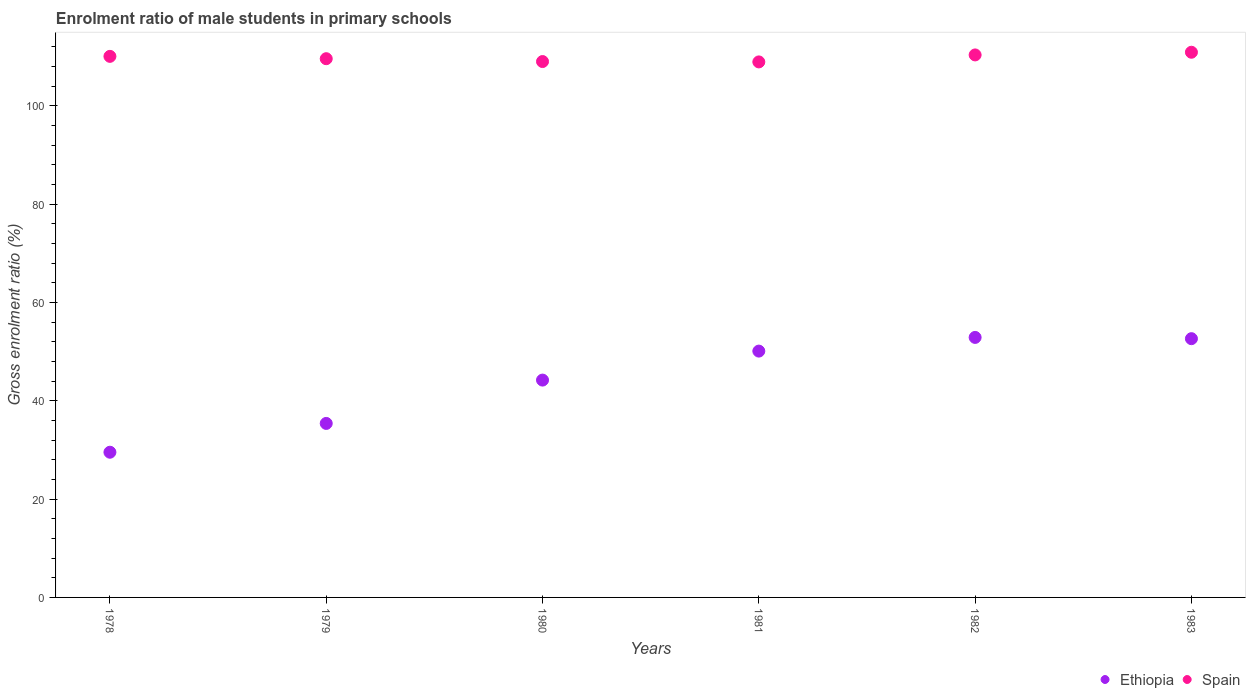How many different coloured dotlines are there?
Ensure brevity in your answer.  2. Is the number of dotlines equal to the number of legend labels?
Provide a short and direct response. Yes. What is the enrolment ratio of male students in primary schools in Ethiopia in 1983?
Provide a short and direct response. 52.64. Across all years, what is the maximum enrolment ratio of male students in primary schools in Ethiopia?
Offer a very short reply. 52.89. Across all years, what is the minimum enrolment ratio of male students in primary schools in Spain?
Ensure brevity in your answer.  108.94. In which year was the enrolment ratio of male students in primary schools in Spain minimum?
Your response must be concise. 1981. What is the total enrolment ratio of male students in primary schools in Ethiopia in the graph?
Keep it short and to the point. 264.79. What is the difference between the enrolment ratio of male students in primary schools in Spain in 1978 and that in 1981?
Keep it short and to the point. 1.13. What is the difference between the enrolment ratio of male students in primary schools in Spain in 1983 and the enrolment ratio of male students in primary schools in Ethiopia in 1978?
Make the answer very short. 81.37. What is the average enrolment ratio of male students in primary schools in Spain per year?
Your answer should be compact. 109.82. In the year 1981, what is the difference between the enrolment ratio of male students in primary schools in Ethiopia and enrolment ratio of male students in primary schools in Spain?
Your response must be concise. -58.83. In how many years, is the enrolment ratio of male students in primary schools in Spain greater than 16 %?
Keep it short and to the point. 6. What is the ratio of the enrolment ratio of male students in primary schools in Ethiopia in 1980 to that in 1982?
Your answer should be very brief. 0.84. Is the enrolment ratio of male students in primary schools in Ethiopia in 1979 less than that in 1981?
Your answer should be compact. Yes. What is the difference between the highest and the second highest enrolment ratio of male students in primary schools in Spain?
Make the answer very short. 0.54. What is the difference between the highest and the lowest enrolment ratio of male students in primary schools in Ethiopia?
Your answer should be very brief. 23.36. Does the enrolment ratio of male students in primary schools in Spain monotonically increase over the years?
Your answer should be compact. No. Is the enrolment ratio of male students in primary schools in Ethiopia strictly greater than the enrolment ratio of male students in primary schools in Spain over the years?
Offer a terse response. No. How many years are there in the graph?
Make the answer very short. 6. Does the graph contain grids?
Provide a succinct answer. No. Where does the legend appear in the graph?
Offer a terse response. Bottom right. What is the title of the graph?
Provide a succinct answer. Enrolment ratio of male students in primary schools. What is the label or title of the X-axis?
Your answer should be compact. Years. What is the Gross enrolment ratio (%) in Ethiopia in 1978?
Keep it short and to the point. 29.54. What is the Gross enrolment ratio (%) of Spain in 1978?
Your answer should be very brief. 110.07. What is the Gross enrolment ratio (%) in Ethiopia in 1979?
Provide a short and direct response. 35.4. What is the Gross enrolment ratio (%) in Spain in 1979?
Your answer should be compact. 109.59. What is the Gross enrolment ratio (%) in Ethiopia in 1980?
Keep it short and to the point. 44.21. What is the Gross enrolment ratio (%) of Spain in 1980?
Your answer should be compact. 109.02. What is the Gross enrolment ratio (%) in Ethiopia in 1981?
Your response must be concise. 50.11. What is the Gross enrolment ratio (%) of Spain in 1981?
Your response must be concise. 108.94. What is the Gross enrolment ratio (%) of Ethiopia in 1982?
Your answer should be compact. 52.89. What is the Gross enrolment ratio (%) in Spain in 1982?
Keep it short and to the point. 110.36. What is the Gross enrolment ratio (%) in Ethiopia in 1983?
Provide a succinct answer. 52.64. What is the Gross enrolment ratio (%) of Spain in 1983?
Ensure brevity in your answer.  110.91. Across all years, what is the maximum Gross enrolment ratio (%) of Ethiopia?
Keep it short and to the point. 52.89. Across all years, what is the maximum Gross enrolment ratio (%) in Spain?
Make the answer very short. 110.91. Across all years, what is the minimum Gross enrolment ratio (%) of Ethiopia?
Your response must be concise. 29.54. Across all years, what is the minimum Gross enrolment ratio (%) in Spain?
Provide a short and direct response. 108.94. What is the total Gross enrolment ratio (%) of Ethiopia in the graph?
Provide a succinct answer. 264.79. What is the total Gross enrolment ratio (%) in Spain in the graph?
Offer a very short reply. 658.89. What is the difference between the Gross enrolment ratio (%) in Ethiopia in 1978 and that in 1979?
Provide a succinct answer. -5.86. What is the difference between the Gross enrolment ratio (%) in Spain in 1978 and that in 1979?
Give a very brief answer. 0.48. What is the difference between the Gross enrolment ratio (%) in Ethiopia in 1978 and that in 1980?
Ensure brevity in your answer.  -14.68. What is the difference between the Gross enrolment ratio (%) of Spain in 1978 and that in 1980?
Offer a very short reply. 1.06. What is the difference between the Gross enrolment ratio (%) of Ethiopia in 1978 and that in 1981?
Your response must be concise. -20.57. What is the difference between the Gross enrolment ratio (%) in Spain in 1978 and that in 1981?
Provide a short and direct response. 1.13. What is the difference between the Gross enrolment ratio (%) of Ethiopia in 1978 and that in 1982?
Your response must be concise. -23.36. What is the difference between the Gross enrolment ratio (%) of Spain in 1978 and that in 1982?
Provide a succinct answer. -0.29. What is the difference between the Gross enrolment ratio (%) of Ethiopia in 1978 and that in 1983?
Your answer should be compact. -23.1. What is the difference between the Gross enrolment ratio (%) in Spain in 1978 and that in 1983?
Offer a very short reply. -0.84. What is the difference between the Gross enrolment ratio (%) in Ethiopia in 1979 and that in 1980?
Your response must be concise. -8.81. What is the difference between the Gross enrolment ratio (%) of Spain in 1979 and that in 1980?
Your answer should be compact. 0.58. What is the difference between the Gross enrolment ratio (%) of Ethiopia in 1979 and that in 1981?
Your response must be concise. -14.71. What is the difference between the Gross enrolment ratio (%) in Spain in 1979 and that in 1981?
Make the answer very short. 0.65. What is the difference between the Gross enrolment ratio (%) in Ethiopia in 1979 and that in 1982?
Keep it short and to the point. -17.5. What is the difference between the Gross enrolment ratio (%) of Spain in 1979 and that in 1982?
Offer a very short reply. -0.77. What is the difference between the Gross enrolment ratio (%) of Ethiopia in 1979 and that in 1983?
Offer a terse response. -17.24. What is the difference between the Gross enrolment ratio (%) in Spain in 1979 and that in 1983?
Ensure brevity in your answer.  -1.31. What is the difference between the Gross enrolment ratio (%) in Ethiopia in 1980 and that in 1981?
Keep it short and to the point. -5.9. What is the difference between the Gross enrolment ratio (%) of Spain in 1980 and that in 1981?
Ensure brevity in your answer.  0.07. What is the difference between the Gross enrolment ratio (%) in Ethiopia in 1980 and that in 1982?
Offer a terse response. -8.68. What is the difference between the Gross enrolment ratio (%) in Spain in 1980 and that in 1982?
Ensure brevity in your answer.  -1.35. What is the difference between the Gross enrolment ratio (%) in Ethiopia in 1980 and that in 1983?
Provide a succinct answer. -8.43. What is the difference between the Gross enrolment ratio (%) in Spain in 1980 and that in 1983?
Offer a very short reply. -1.89. What is the difference between the Gross enrolment ratio (%) in Ethiopia in 1981 and that in 1982?
Offer a terse response. -2.78. What is the difference between the Gross enrolment ratio (%) of Spain in 1981 and that in 1982?
Give a very brief answer. -1.42. What is the difference between the Gross enrolment ratio (%) of Ethiopia in 1981 and that in 1983?
Provide a succinct answer. -2.53. What is the difference between the Gross enrolment ratio (%) of Spain in 1981 and that in 1983?
Offer a very short reply. -1.97. What is the difference between the Gross enrolment ratio (%) in Ethiopia in 1982 and that in 1983?
Offer a terse response. 0.26. What is the difference between the Gross enrolment ratio (%) of Spain in 1982 and that in 1983?
Provide a succinct answer. -0.54. What is the difference between the Gross enrolment ratio (%) in Ethiopia in 1978 and the Gross enrolment ratio (%) in Spain in 1979?
Offer a very short reply. -80.06. What is the difference between the Gross enrolment ratio (%) in Ethiopia in 1978 and the Gross enrolment ratio (%) in Spain in 1980?
Offer a very short reply. -79.48. What is the difference between the Gross enrolment ratio (%) in Ethiopia in 1978 and the Gross enrolment ratio (%) in Spain in 1981?
Make the answer very short. -79.4. What is the difference between the Gross enrolment ratio (%) in Ethiopia in 1978 and the Gross enrolment ratio (%) in Spain in 1982?
Offer a terse response. -80.83. What is the difference between the Gross enrolment ratio (%) of Ethiopia in 1978 and the Gross enrolment ratio (%) of Spain in 1983?
Give a very brief answer. -81.37. What is the difference between the Gross enrolment ratio (%) in Ethiopia in 1979 and the Gross enrolment ratio (%) in Spain in 1980?
Provide a succinct answer. -73.62. What is the difference between the Gross enrolment ratio (%) in Ethiopia in 1979 and the Gross enrolment ratio (%) in Spain in 1981?
Offer a very short reply. -73.54. What is the difference between the Gross enrolment ratio (%) of Ethiopia in 1979 and the Gross enrolment ratio (%) of Spain in 1982?
Make the answer very short. -74.96. What is the difference between the Gross enrolment ratio (%) in Ethiopia in 1979 and the Gross enrolment ratio (%) in Spain in 1983?
Make the answer very short. -75.51. What is the difference between the Gross enrolment ratio (%) in Ethiopia in 1980 and the Gross enrolment ratio (%) in Spain in 1981?
Provide a short and direct response. -64.73. What is the difference between the Gross enrolment ratio (%) of Ethiopia in 1980 and the Gross enrolment ratio (%) of Spain in 1982?
Provide a succinct answer. -66.15. What is the difference between the Gross enrolment ratio (%) of Ethiopia in 1980 and the Gross enrolment ratio (%) of Spain in 1983?
Your answer should be compact. -66.69. What is the difference between the Gross enrolment ratio (%) of Ethiopia in 1981 and the Gross enrolment ratio (%) of Spain in 1982?
Provide a succinct answer. -60.25. What is the difference between the Gross enrolment ratio (%) of Ethiopia in 1981 and the Gross enrolment ratio (%) of Spain in 1983?
Your answer should be very brief. -60.8. What is the difference between the Gross enrolment ratio (%) of Ethiopia in 1982 and the Gross enrolment ratio (%) of Spain in 1983?
Your response must be concise. -58.01. What is the average Gross enrolment ratio (%) of Ethiopia per year?
Offer a very short reply. 44.13. What is the average Gross enrolment ratio (%) in Spain per year?
Offer a very short reply. 109.82. In the year 1978, what is the difference between the Gross enrolment ratio (%) of Ethiopia and Gross enrolment ratio (%) of Spain?
Your answer should be very brief. -80.53. In the year 1979, what is the difference between the Gross enrolment ratio (%) of Ethiopia and Gross enrolment ratio (%) of Spain?
Provide a short and direct response. -74.2. In the year 1980, what is the difference between the Gross enrolment ratio (%) in Ethiopia and Gross enrolment ratio (%) in Spain?
Provide a short and direct response. -64.8. In the year 1981, what is the difference between the Gross enrolment ratio (%) in Ethiopia and Gross enrolment ratio (%) in Spain?
Make the answer very short. -58.83. In the year 1982, what is the difference between the Gross enrolment ratio (%) of Ethiopia and Gross enrolment ratio (%) of Spain?
Your response must be concise. -57.47. In the year 1983, what is the difference between the Gross enrolment ratio (%) of Ethiopia and Gross enrolment ratio (%) of Spain?
Keep it short and to the point. -58.27. What is the ratio of the Gross enrolment ratio (%) of Ethiopia in 1978 to that in 1979?
Your answer should be very brief. 0.83. What is the ratio of the Gross enrolment ratio (%) in Spain in 1978 to that in 1979?
Offer a very short reply. 1. What is the ratio of the Gross enrolment ratio (%) of Ethiopia in 1978 to that in 1980?
Offer a terse response. 0.67. What is the ratio of the Gross enrolment ratio (%) in Spain in 1978 to that in 1980?
Provide a short and direct response. 1.01. What is the ratio of the Gross enrolment ratio (%) of Ethiopia in 1978 to that in 1981?
Your answer should be compact. 0.59. What is the ratio of the Gross enrolment ratio (%) in Spain in 1978 to that in 1981?
Make the answer very short. 1.01. What is the ratio of the Gross enrolment ratio (%) in Ethiopia in 1978 to that in 1982?
Make the answer very short. 0.56. What is the ratio of the Gross enrolment ratio (%) of Spain in 1978 to that in 1982?
Provide a short and direct response. 1. What is the ratio of the Gross enrolment ratio (%) of Ethiopia in 1978 to that in 1983?
Provide a succinct answer. 0.56. What is the ratio of the Gross enrolment ratio (%) of Spain in 1978 to that in 1983?
Provide a succinct answer. 0.99. What is the ratio of the Gross enrolment ratio (%) in Ethiopia in 1979 to that in 1980?
Offer a terse response. 0.8. What is the ratio of the Gross enrolment ratio (%) in Spain in 1979 to that in 1980?
Provide a short and direct response. 1.01. What is the ratio of the Gross enrolment ratio (%) of Ethiopia in 1979 to that in 1981?
Offer a terse response. 0.71. What is the ratio of the Gross enrolment ratio (%) of Ethiopia in 1979 to that in 1982?
Your response must be concise. 0.67. What is the ratio of the Gross enrolment ratio (%) in Ethiopia in 1979 to that in 1983?
Offer a terse response. 0.67. What is the ratio of the Gross enrolment ratio (%) of Spain in 1979 to that in 1983?
Offer a terse response. 0.99. What is the ratio of the Gross enrolment ratio (%) of Ethiopia in 1980 to that in 1981?
Provide a short and direct response. 0.88. What is the ratio of the Gross enrolment ratio (%) in Ethiopia in 1980 to that in 1982?
Give a very brief answer. 0.84. What is the ratio of the Gross enrolment ratio (%) in Ethiopia in 1980 to that in 1983?
Give a very brief answer. 0.84. What is the ratio of the Gross enrolment ratio (%) in Spain in 1980 to that in 1983?
Provide a short and direct response. 0.98. What is the ratio of the Gross enrolment ratio (%) of Spain in 1981 to that in 1982?
Your response must be concise. 0.99. What is the ratio of the Gross enrolment ratio (%) in Spain in 1981 to that in 1983?
Give a very brief answer. 0.98. What is the ratio of the Gross enrolment ratio (%) of Spain in 1982 to that in 1983?
Give a very brief answer. 1. What is the difference between the highest and the second highest Gross enrolment ratio (%) in Ethiopia?
Provide a succinct answer. 0.26. What is the difference between the highest and the second highest Gross enrolment ratio (%) in Spain?
Give a very brief answer. 0.54. What is the difference between the highest and the lowest Gross enrolment ratio (%) in Ethiopia?
Give a very brief answer. 23.36. What is the difference between the highest and the lowest Gross enrolment ratio (%) of Spain?
Your answer should be very brief. 1.97. 